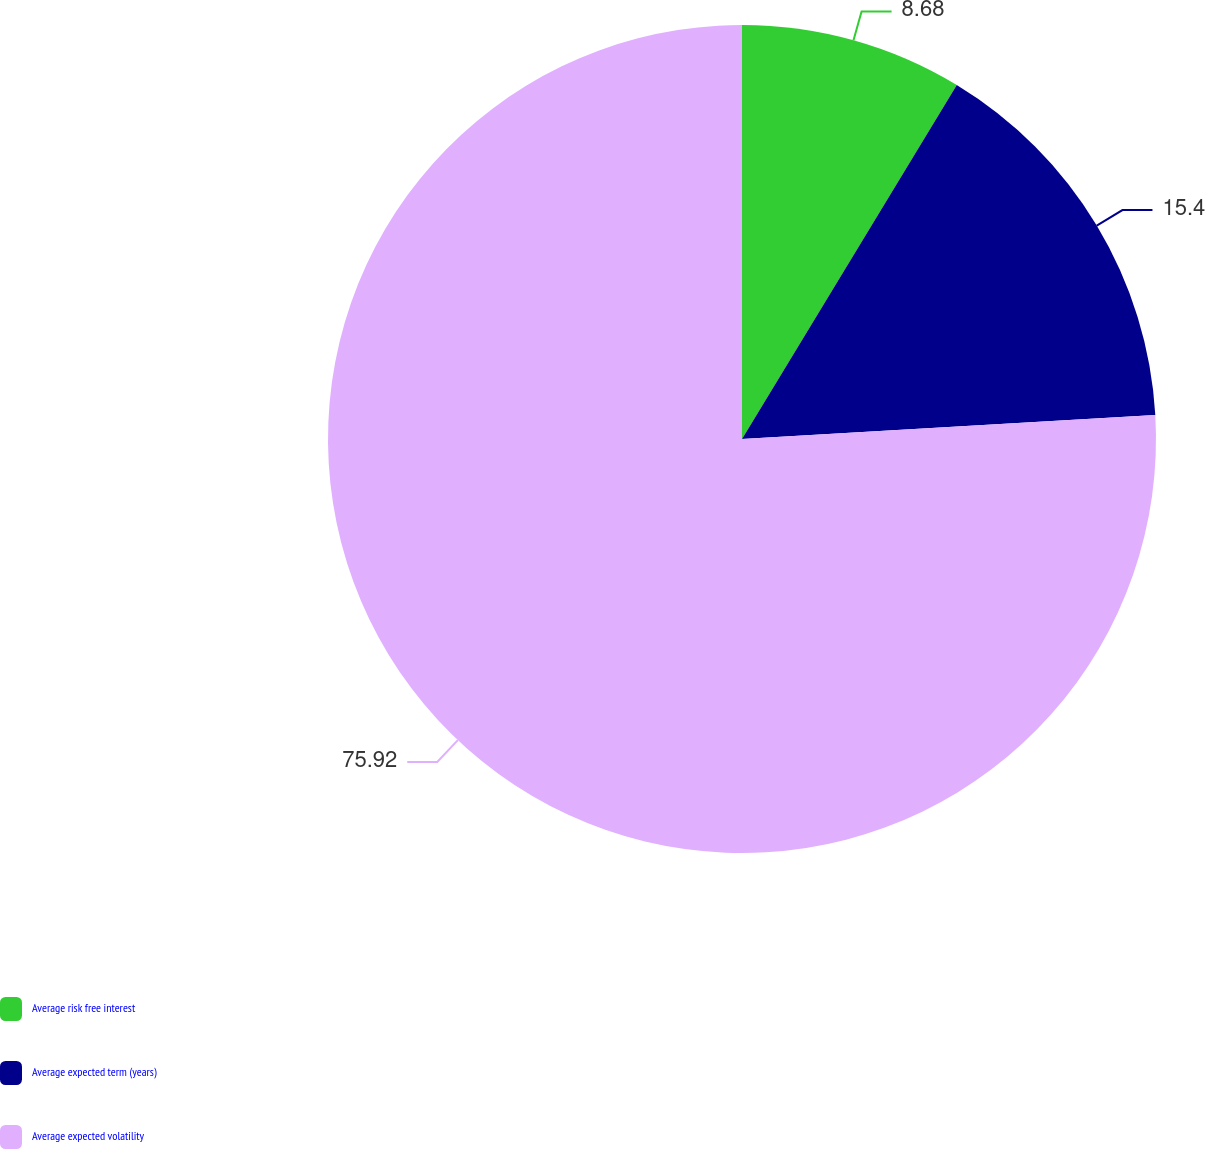<chart> <loc_0><loc_0><loc_500><loc_500><pie_chart><fcel>Average risk free interest<fcel>Average expected term (years)<fcel>Average expected volatility<nl><fcel>8.68%<fcel>15.4%<fcel>75.92%<nl></chart> 